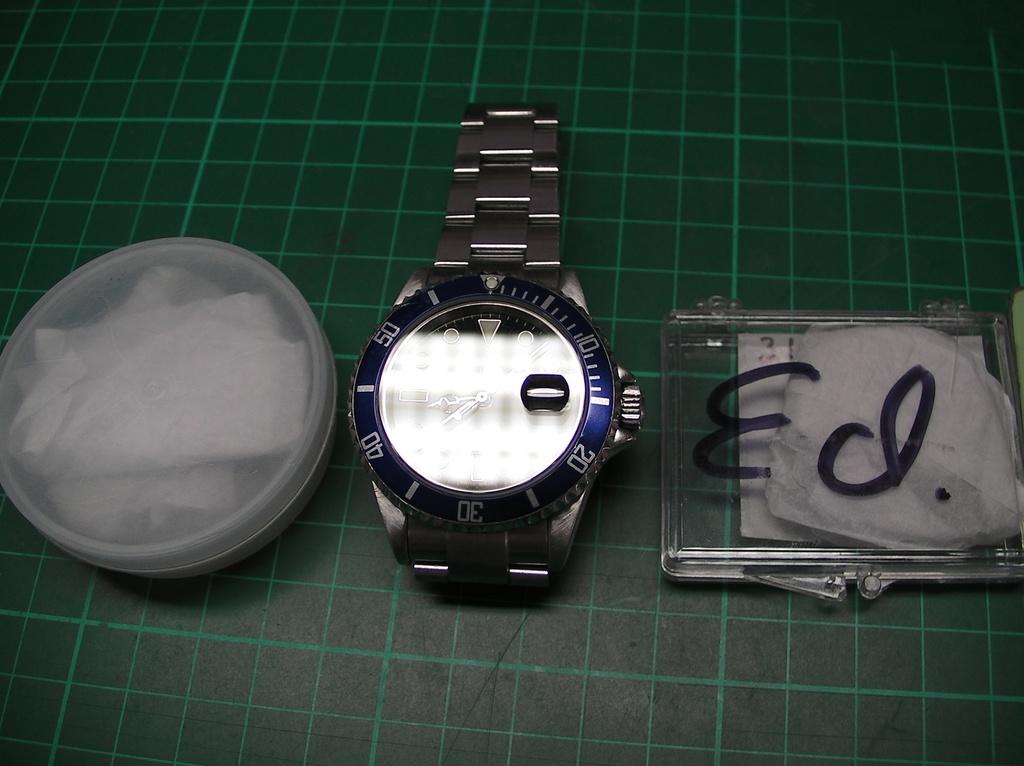Whose name is in black letters?
Offer a terse response. Ed. 